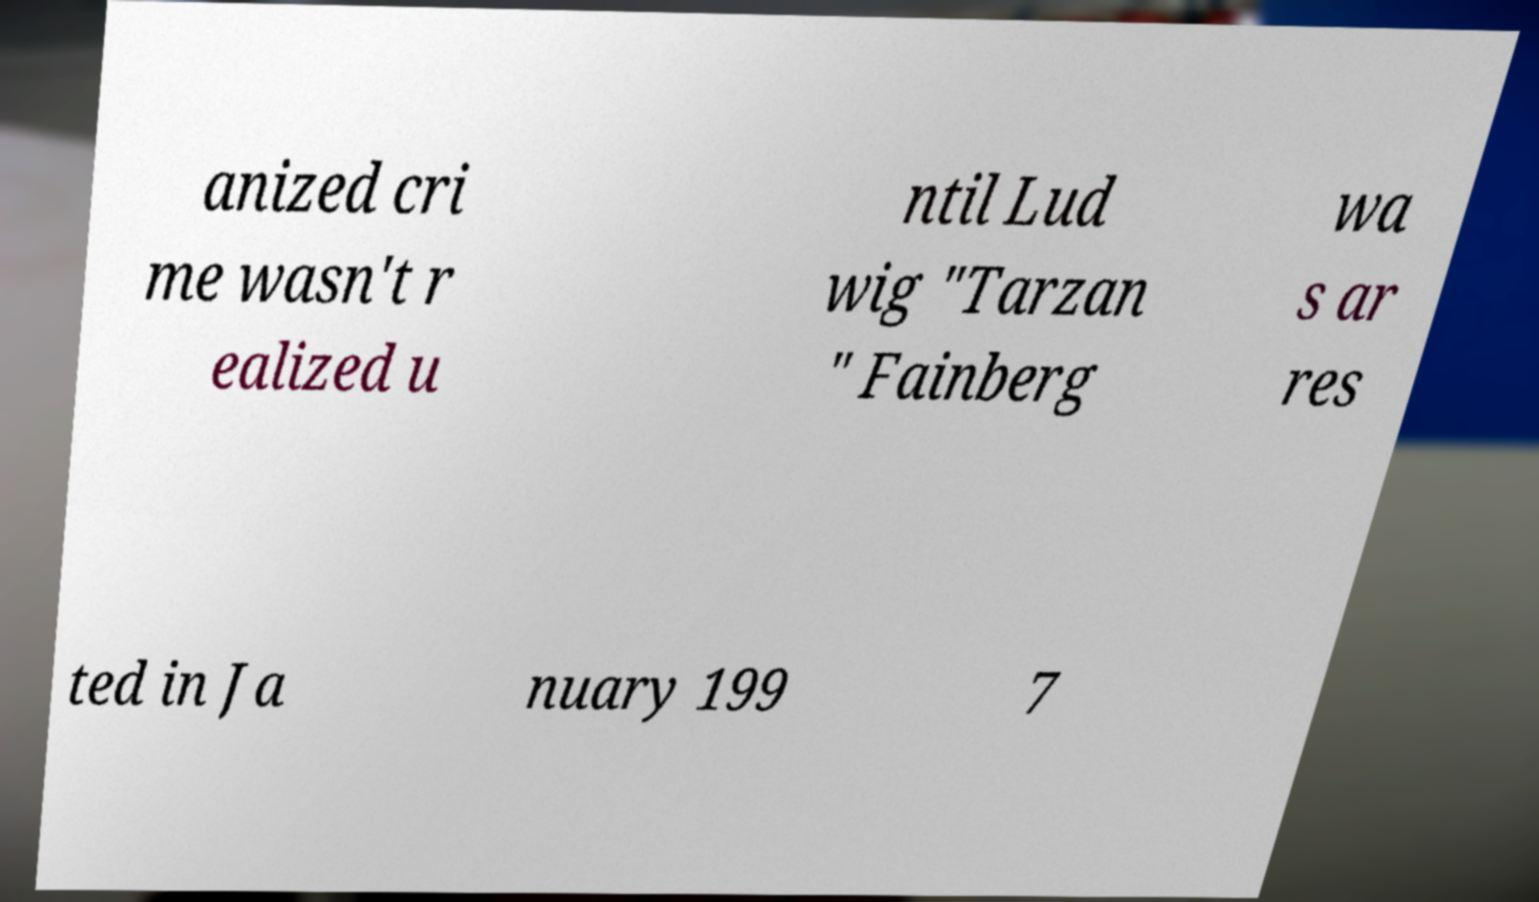Could you assist in decoding the text presented in this image and type it out clearly? anized cri me wasn't r ealized u ntil Lud wig "Tarzan " Fainberg wa s ar res ted in Ja nuary 199 7 